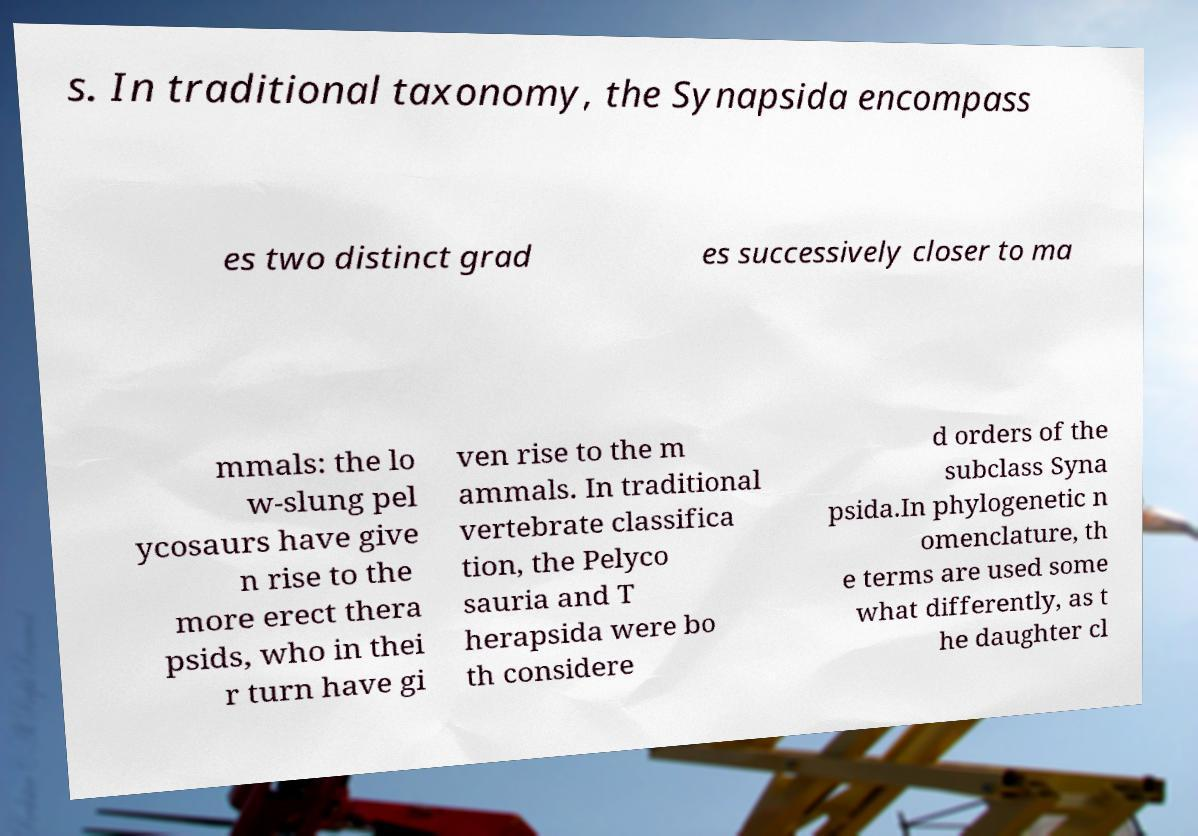Please identify and transcribe the text found in this image. s. In traditional taxonomy, the Synapsida encompass es two distinct grad es successively closer to ma mmals: the lo w-slung pel ycosaurs have give n rise to the more erect thera psids, who in thei r turn have gi ven rise to the m ammals. In traditional vertebrate classifica tion, the Pelyco sauria and T herapsida were bo th considere d orders of the subclass Syna psida.In phylogenetic n omenclature, th e terms are used some what differently, as t he daughter cl 